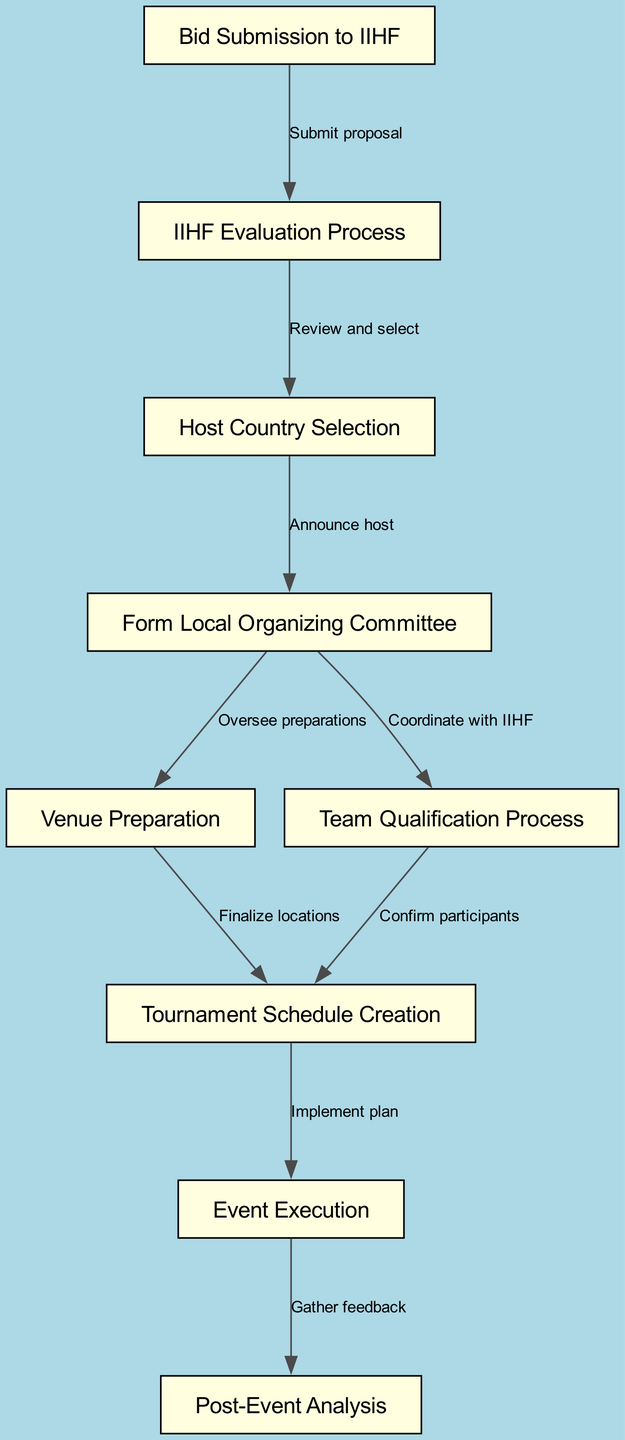What is the first step in hosting an international hockey tournament? The flow chart indicates that the first node is "Bid Submission to IIHF," which represents the initial step in the process.
Answer: Bid Submission to IIHF How many nodes are in the diagram? By counting the nodes listed, there are a total of 9 distinct steps in the process shown in the diagram.
Answer: 9 What step follows the "IIHF Evaluation Process"? The diagram shows that after the "IIHF Evaluation Process," the next step is "Host Country Selection," indicating a direct flow from evaluation to selection.
Answer: Host Country Selection What action is taken after forming the Local Organizing Committee? According to the flow chart, once the "Local Organizing Committee" is formed, the next step is to "Venue Preparation," indicating the organizational structure moving into practical arrangements.
Answer: Venue Preparation Which step involves confirming participants? The diagram specifies that the "Team Qualification Process" is the step dedicated to confirming participants for the tournament.
Answer: Team Qualification Process How are the tournament schedule and event execution connected? The flow chart indicates that after the "Tournament Schedule Creation," the next step is "Event Execution," showing a clear progression from planning to implementation.
Answer: Event Execution What feedback is gathered after the tournament? The flow chart indicates that after "Event Execution," the process leads to "Post-Event Analysis," where feedback is collected for future evaluations.
Answer: Post-Event Analysis Which two processes are overseen by the Local Organizing Committee? The diagram illustrates that the "Local Organizing Committee" oversees both "Venue Preparation" and "Team Qualification Process," showing its role in both logistics and participant engagement.
Answer: Venue Preparation and Team Qualification Process What does the edge "Gather feedback" imply about post-event activities? The edge labeled "Gather feedback" implies that post-event activities focus on collecting insights and evaluations to assess the tournament's success and areas for improvement.
Answer: Gather feedback 